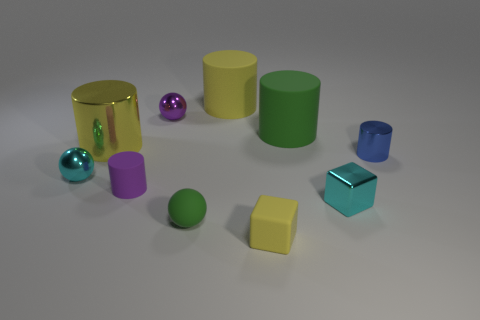Subtract all green rubber cylinders. How many cylinders are left? 4 Subtract all blue cylinders. How many cylinders are left? 4 Subtract all cubes. How many objects are left? 8 Subtract 5 cylinders. How many cylinders are left? 0 Add 4 cyan objects. How many cyan objects exist? 6 Subtract 0 red spheres. How many objects are left? 10 Subtract all brown spheres. Subtract all brown cylinders. How many spheres are left? 3 Subtract all yellow cylinders. How many cyan cubes are left? 1 Subtract all large purple matte blocks. Subtract all cyan blocks. How many objects are left? 9 Add 4 small matte things. How many small matte things are left? 7 